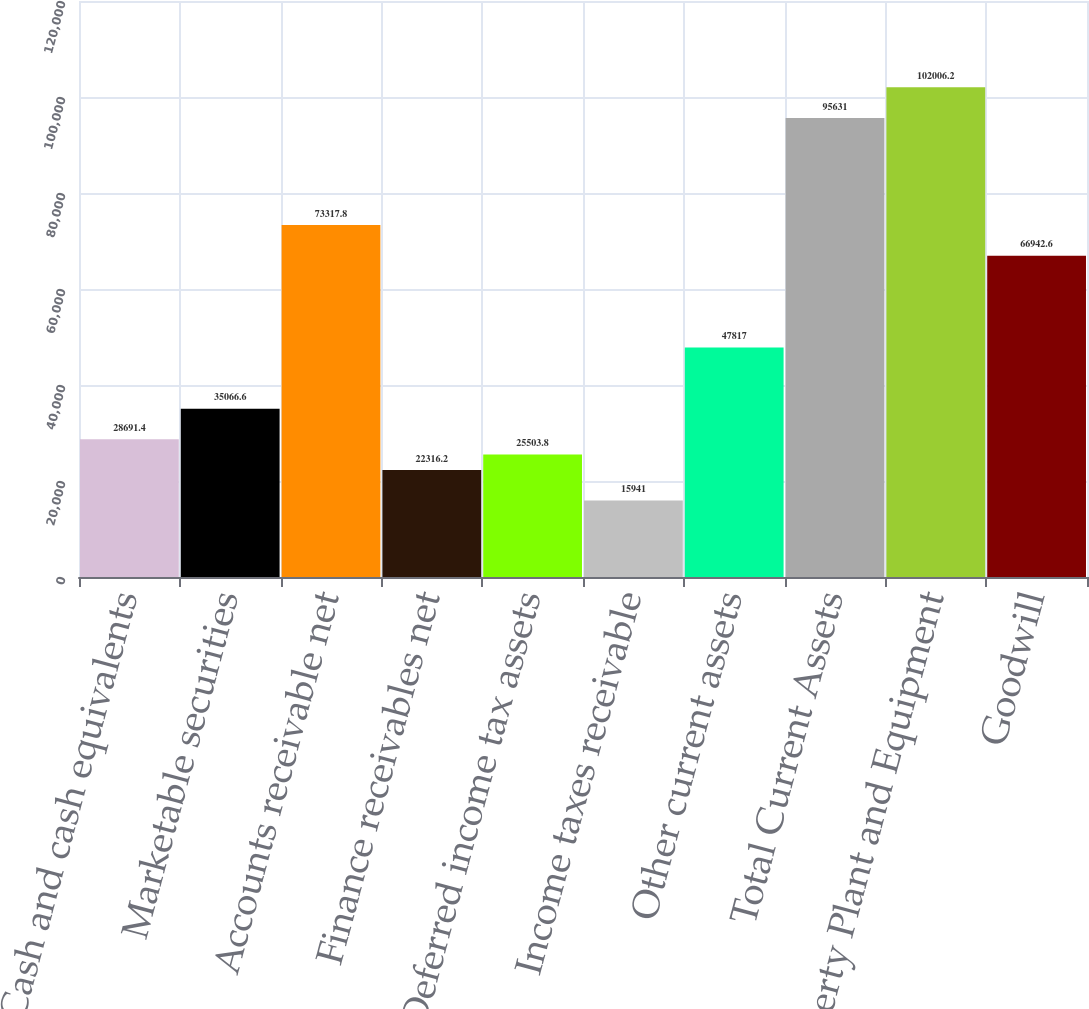Convert chart. <chart><loc_0><loc_0><loc_500><loc_500><bar_chart><fcel>Cash and cash equivalents<fcel>Marketable securities<fcel>Accounts receivable net<fcel>Finance receivables net<fcel>Deferred income tax assets<fcel>Income taxes receivable<fcel>Other current assets<fcel>Total Current Assets<fcel>Property Plant and Equipment<fcel>Goodwill<nl><fcel>28691.4<fcel>35066.6<fcel>73317.8<fcel>22316.2<fcel>25503.8<fcel>15941<fcel>47817<fcel>95631<fcel>102006<fcel>66942.6<nl></chart> 